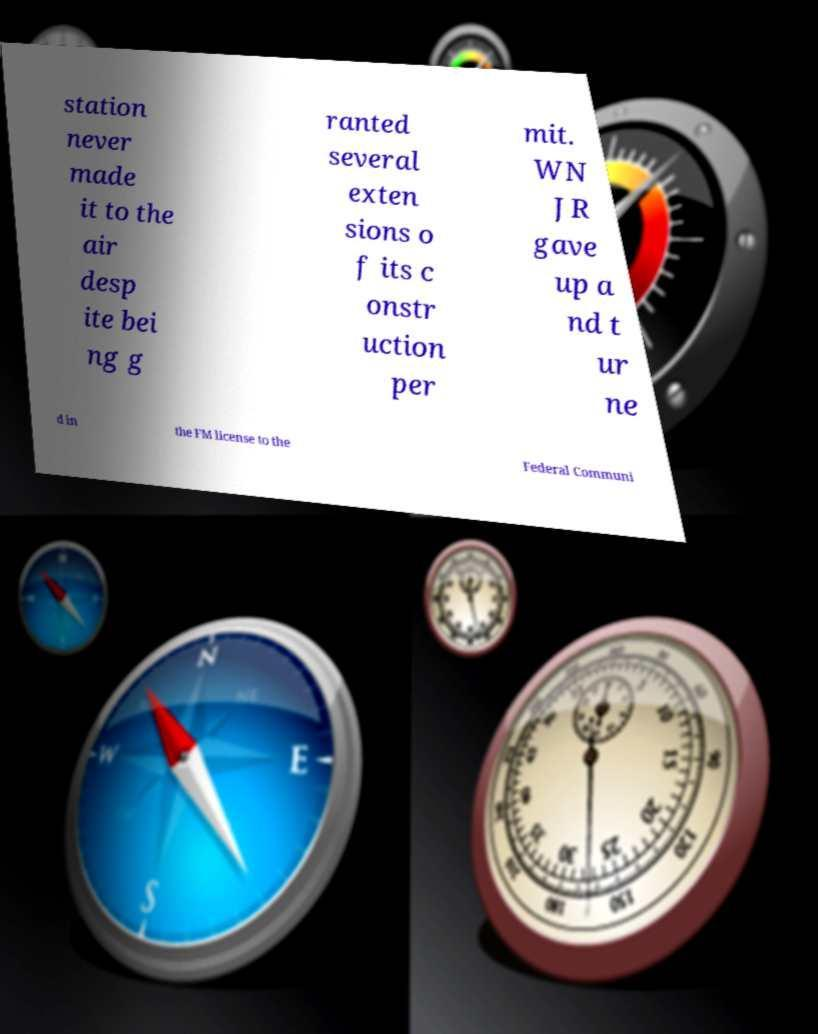Could you assist in decoding the text presented in this image and type it out clearly? station never made it to the air desp ite bei ng g ranted several exten sions o f its c onstr uction per mit. WN JR gave up a nd t ur ne d in the FM license to the Federal Communi 